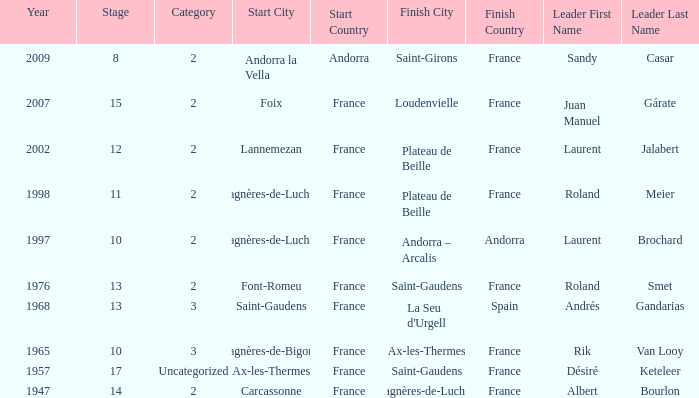Name the start of an event in Catagory 2 of the year 1947. Carcassonne. 